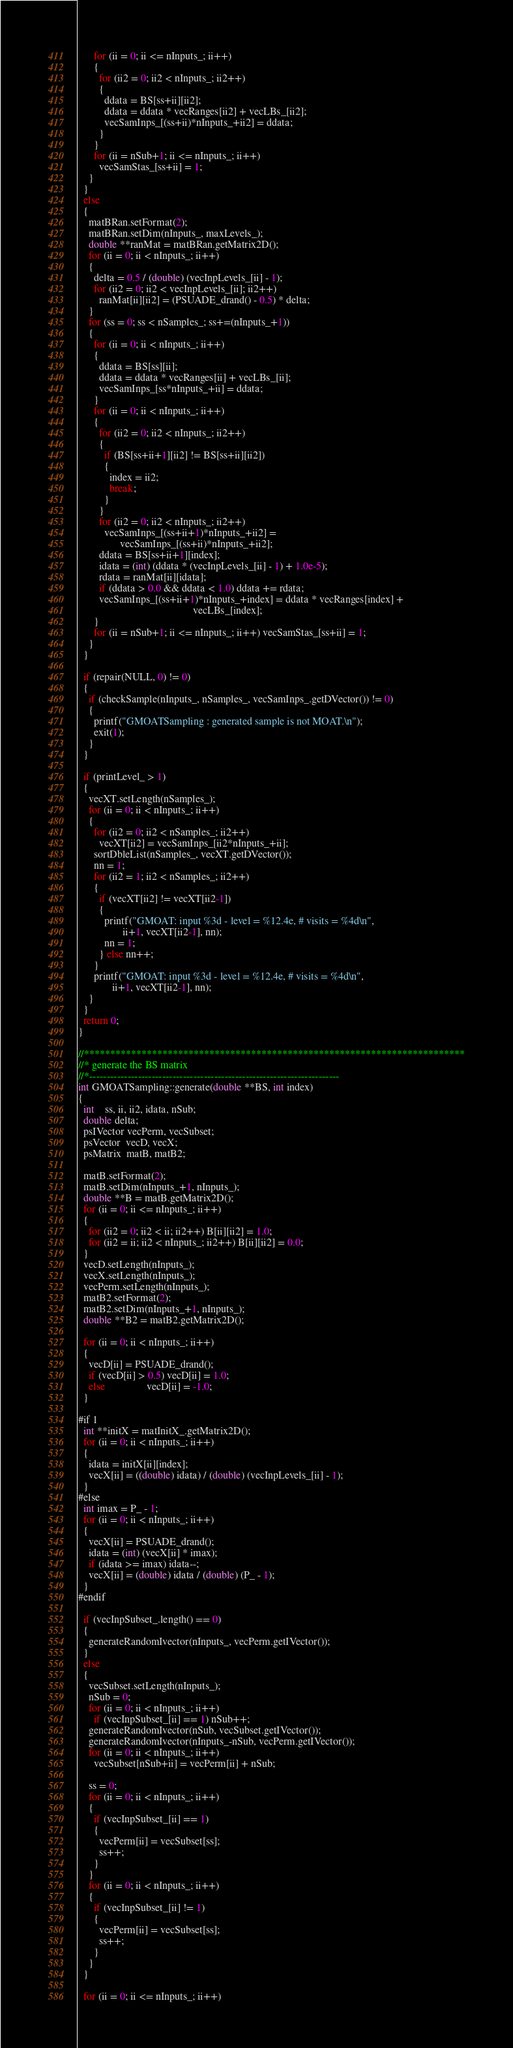<code> <loc_0><loc_0><loc_500><loc_500><_C++_>      for (ii = 0; ii <= nInputs_; ii++)
      {
        for (ii2 = 0; ii2 < nInputs_; ii2++)
        {
          ddata = BS[ss+ii][ii2];
          ddata = ddata * vecRanges[ii2] + vecLBs_[ii2];
          vecSamInps_[(ss+ii)*nInputs_+ii2] = ddata;
        }
      }
      for (ii = nSub+1; ii <= nInputs_; ii++)
        vecSamStas_[ss+ii] = 1;
    }
  }    
  else
  {
    matBRan.setFormat(2);
    matBRan.setDim(nInputs_, maxLevels_);
    double **ranMat = matBRan.getMatrix2D();
    for (ii = 0; ii < nInputs_; ii++)
    {
      delta = 0.5 / (double) (vecInpLevels_[ii] - 1);
      for (ii2 = 0; ii2 < vecInpLevels_[ii]; ii2++)
        ranMat[ii][ii2] = (PSUADE_drand() - 0.5) * delta;
    } 
    for (ss = 0; ss < nSamples_; ss+=(nInputs_+1))
    {
      for (ii = 0; ii < nInputs_; ii++)
      {
        ddata = BS[ss][ii];
        ddata = ddata * vecRanges[ii] + vecLBs_[ii];
        vecSamInps_[ss*nInputs_+ii] = ddata;
      }
      for (ii = 0; ii < nInputs_; ii++)
      {
        for (ii2 = 0; ii2 < nInputs_; ii2++)
        {
          if (BS[ss+ii+1][ii2] != BS[ss+ii][ii2])
          {
            index = ii2; 
            break;
          }
        }
        for (ii2 = 0; ii2 < nInputs_; ii2++)
          vecSamInps_[(ss+ii+1)*nInputs_+ii2] = 
                vecSamInps_[(ss+ii)*nInputs_+ii2];
        ddata = BS[ss+ii+1][index];
        idata = (int) (ddata * (vecInpLevels_[ii] - 1) + 1.0e-5);
        rdata = ranMat[ii][idata];
        if (ddata > 0.0 && ddata < 1.0) ddata += rdata;
        vecSamInps_[(ss+ii+1)*nInputs_+index] = ddata * vecRanges[index] + 
                                            vecLBs_[index];
      }
      for (ii = nSub+1; ii <= nInputs_; ii++) vecSamStas_[ss+ii] = 1;
    }
  }    

  if (repair(NULL, 0) != 0)
  {
    if (checkSample(nInputs_, nSamples_, vecSamInps_.getDVector()) != 0)
    {
      printf("GMOATSampling : generated sample is not MOAT.\n");
      exit(1);
    }
  }

  if (printLevel_ > 1)
  {
    vecXT.setLength(nSamples_);
    for (ii = 0; ii < nInputs_; ii++)
    {
      for (ii2 = 0; ii2 < nSamples_; ii2++)
        vecXT[ii2] = vecSamInps_[ii2*nInputs_+ii];
      sortDbleList(nSamples_, vecXT.getDVector());
      nn = 1;
      for (ii2 = 1; ii2 < nSamples_; ii2++)
      {
        if (vecXT[ii2] != vecXT[ii2-1])
        {
          printf("GMOAT: input %3d - level = %12.4e, # visits = %4d\n",
                 ii+1, vecXT[ii2-1], nn);
          nn = 1;
        } else nn++;
      }
      printf("GMOAT: input %3d - level = %12.4e, # visits = %4d\n",
             ii+1, vecXT[ii2-1], nn);
    }
  }
  return 0;
}

//*************************************************************************
//* generate the BS matrix
//*------------------------------------------------------------------------
int GMOATSampling::generate(double **BS, int index)
{
  int    ss, ii, ii2, idata, nSub;
  double delta;
  psIVector vecPerm, vecSubset;
  psVector  vecD, vecX;
  psMatrix  matB, matB2;

  matB.setFormat(2);
  matB.setDim(nInputs_+1, nInputs_);
  double **B = matB.getMatrix2D();
  for (ii = 0; ii <= nInputs_; ii++)
  {
    for (ii2 = 0; ii2 < ii; ii2++) B[ii][ii2] = 1.0;
    for (ii2 = ii; ii2 < nInputs_; ii2++) B[ii][ii2] = 0.0;
  }
  vecD.setLength(nInputs_);
  vecX.setLength(nInputs_);
  vecPerm.setLength(nInputs_);
  matB2.setFormat(2);
  matB2.setDim(nInputs_+1, nInputs_);
  double **B2 = matB2.getMatrix2D();

  for (ii = 0; ii < nInputs_; ii++)
  {
    vecD[ii] = PSUADE_drand();
    if (vecD[ii] > 0.5) vecD[ii] = 1.0;
    else                vecD[ii] = -1.0;
  }

#if 1 
  int **initX = matInitX_.getMatrix2D();
  for (ii = 0; ii < nInputs_; ii++)
  {
    idata = initX[ii][index];
    vecX[ii] = ((double) idata) / (double) (vecInpLevels_[ii] - 1);
  }
#else
  int imax = P_ - 1;
  for (ii = 0; ii < nInputs_; ii++)
  {
    vecX[ii] = PSUADE_drand();
    idata = (int) (vecX[ii] * imax);
    if (idata >= imax) idata--;
    vecX[ii] = (double) idata / (double) (P_ - 1);
  }
#endif

  if (vecInpSubset_.length() == 0)
  {
    generateRandomIvector(nInputs_, vecPerm.getIVector());
  }
  else
  {
    vecSubset.setLength(nInputs_);
    nSub = 0;
    for (ii = 0; ii < nInputs_; ii++)
      if (vecInpSubset_[ii] == 1) nSub++;
    generateRandomIvector(nSub, vecSubset.getIVector());
    generateRandomIvector(nInputs_-nSub, vecPerm.getIVector());
    for (ii = 0; ii < nInputs_; ii++)
      vecSubset[nSub+ii] = vecPerm[ii] + nSub;

    ss = 0;
    for (ii = 0; ii < nInputs_; ii++)
    {
      if (vecInpSubset_[ii] == 1)
      {
        vecPerm[ii] = vecSubset[ss];
        ss++;
      }
    }
    for (ii = 0; ii < nInputs_; ii++)
    {
      if (vecInpSubset_[ii] != 1)
      {
        vecPerm[ii] = vecSubset[ss];
        ss++;
      }
    }
  }

  for (ii = 0; ii <= nInputs_; ii++)</code> 